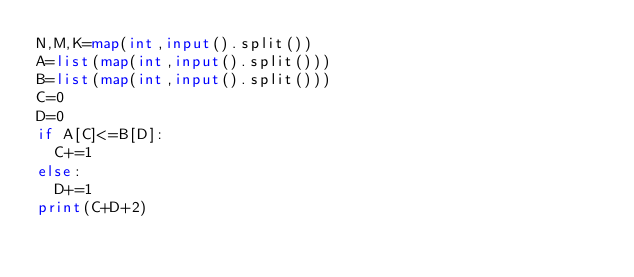<code> <loc_0><loc_0><loc_500><loc_500><_Python_>N,M,K=map(int,input().split())
A=list(map(int,input().split()))
B=list(map(int,input().split()))
C=0
D=0
if A[C]<=B[D]:
  C+=1
else:
  D+=1
print(C+D+2)</code> 